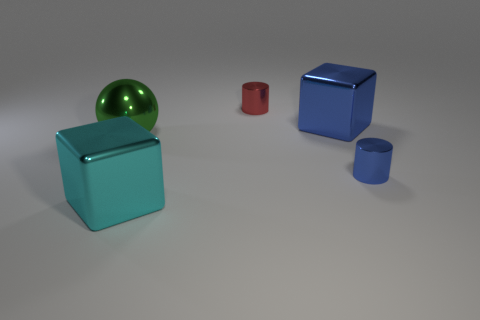How many tiny things are either cyan cylinders or red cylinders?
Your answer should be compact. 1. Is the color of the cylinder behind the large green shiny object the same as the metallic cube that is to the right of the big cyan shiny object?
Your response must be concise. No. How many other objects are the same color as the metallic sphere?
Ensure brevity in your answer.  0. The thing on the left side of the cyan shiny cube has what shape?
Offer a terse response. Sphere. Are there fewer small spheres than big green shiny objects?
Give a very brief answer. Yes. Is the tiny cylinder in front of the small red metallic object made of the same material as the green object?
Keep it short and to the point. Yes. Is there any other thing that has the same size as the red cylinder?
Your answer should be very brief. Yes. There is a tiny blue cylinder; are there any green shiny objects left of it?
Ensure brevity in your answer.  Yes. There is a big cube to the left of the block behind the tiny cylinder that is right of the red object; what is its color?
Keep it short and to the point. Cyan. There is a cyan metal thing that is the same size as the green thing; what shape is it?
Provide a short and direct response. Cube. 